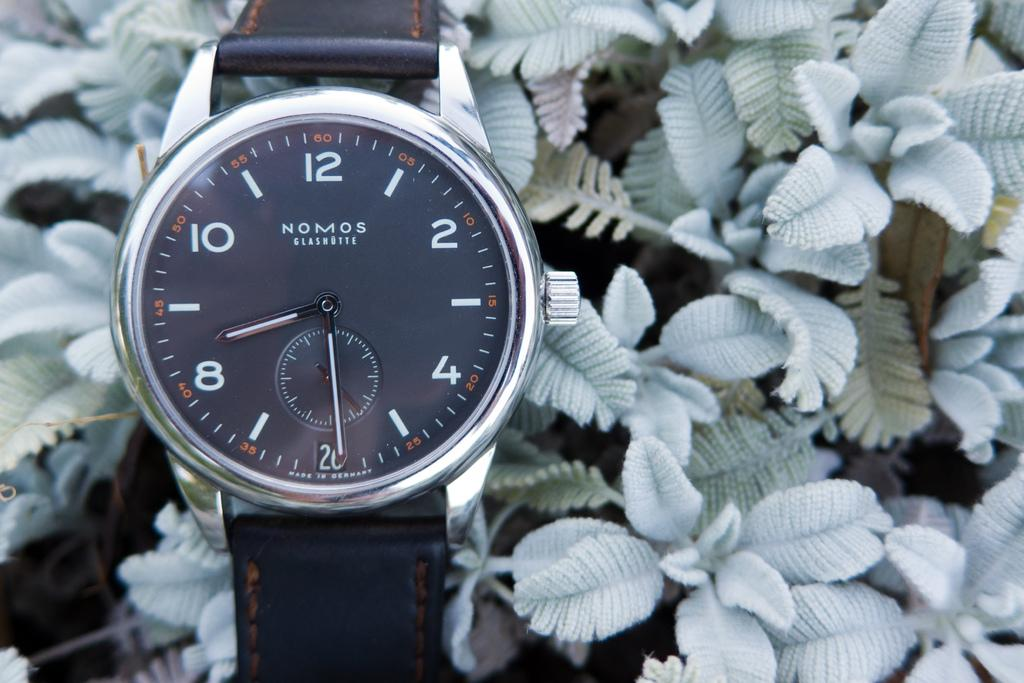Provide a one-sentence caption for the provided image. A Nomos watch has a black face and a black strap. 